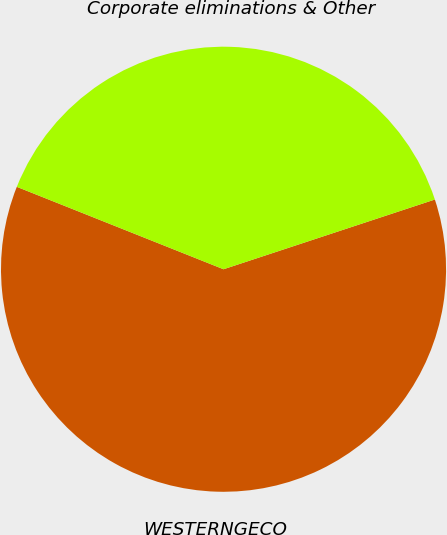Convert chart to OTSL. <chart><loc_0><loc_0><loc_500><loc_500><pie_chart><fcel>WESTERNGECO<fcel>Corporate eliminations & Other<nl><fcel>61.11%<fcel>38.89%<nl></chart> 